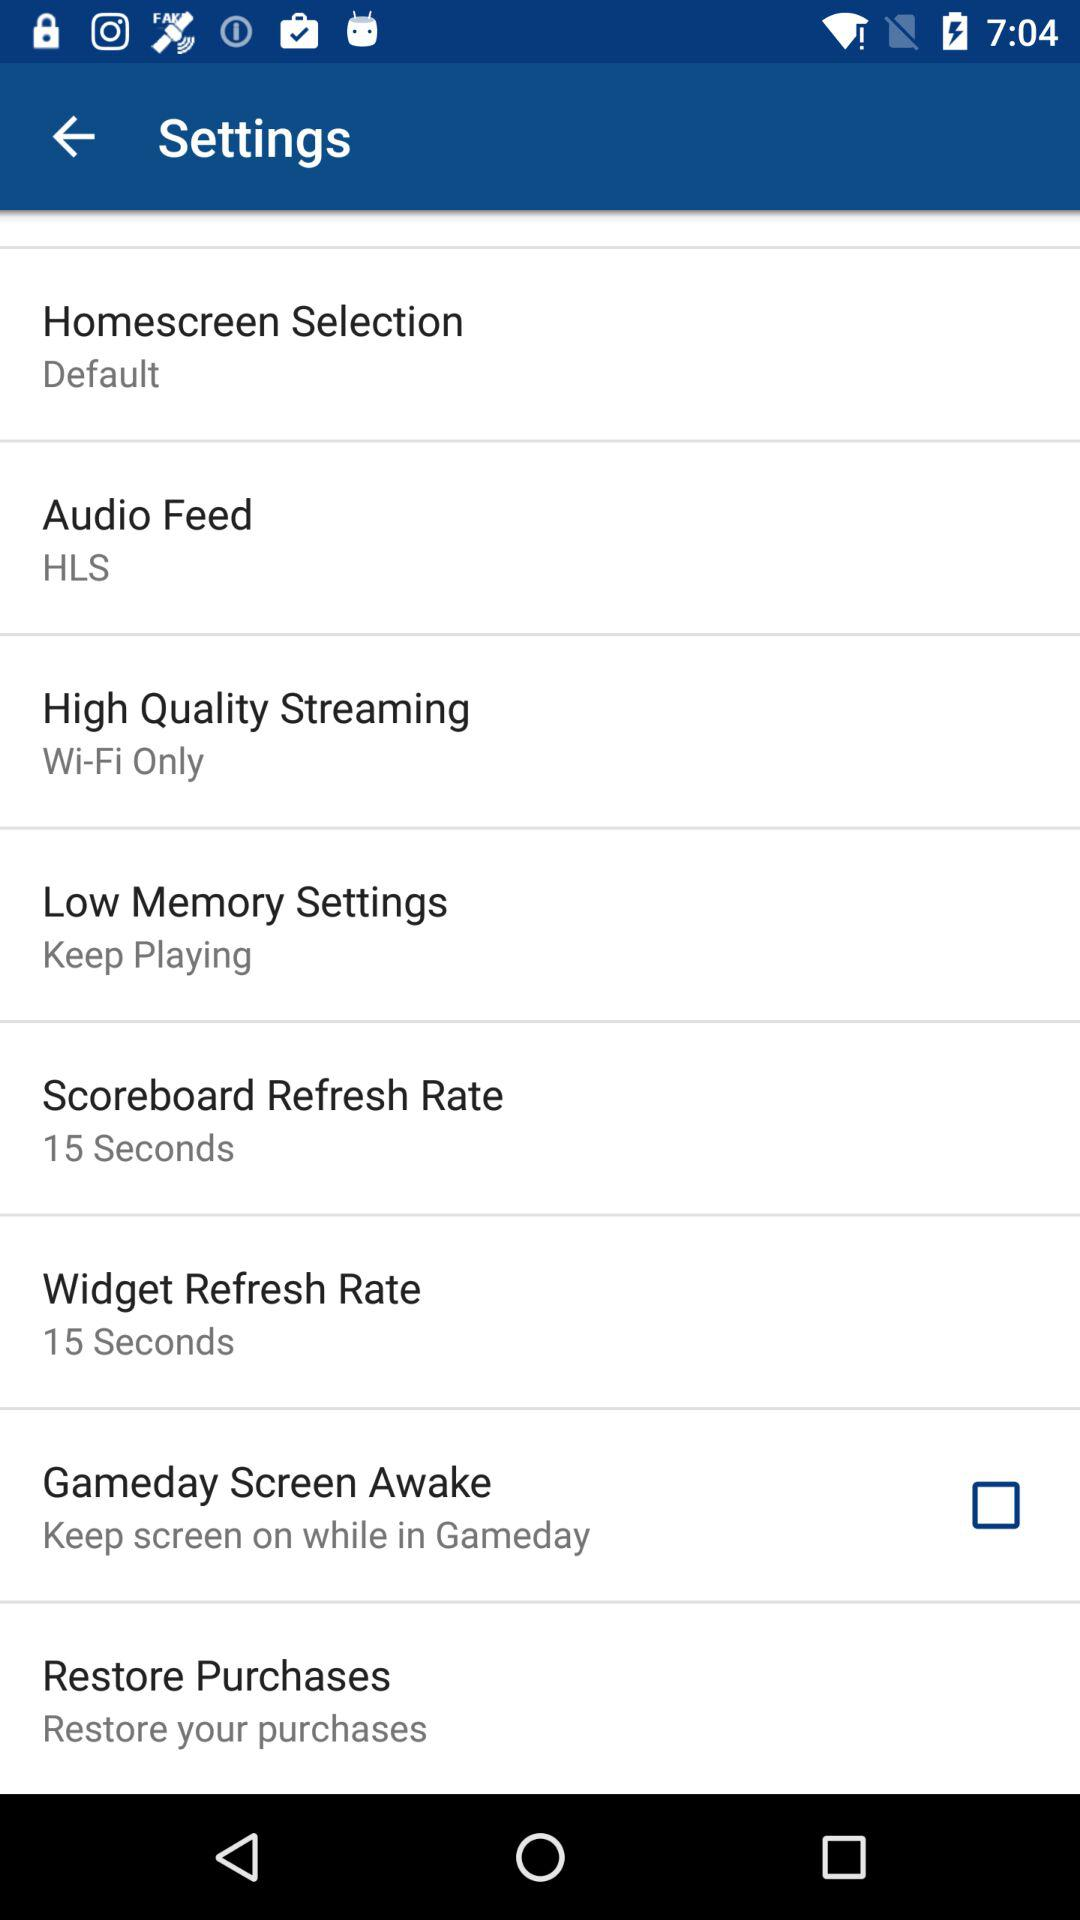What is the setting for the audio feed? The setting for the audio feed is HLS. 